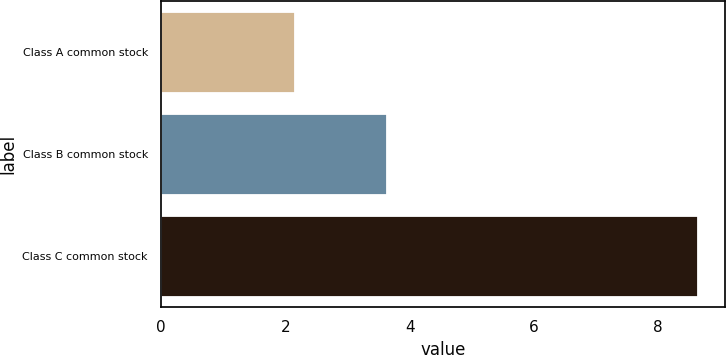Convert chart. <chart><loc_0><loc_0><loc_500><loc_500><bar_chart><fcel>Class A common stock<fcel>Class B common stock<fcel>Class C common stock<nl><fcel>2.16<fcel>3.63<fcel>8.65<nl></chart> 